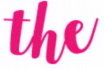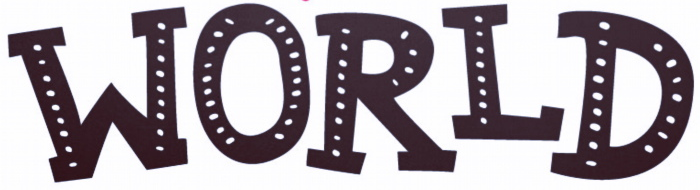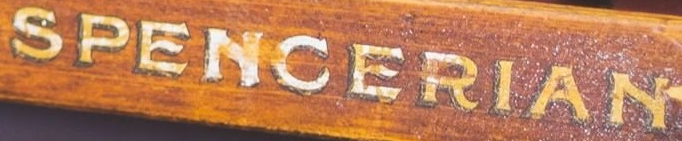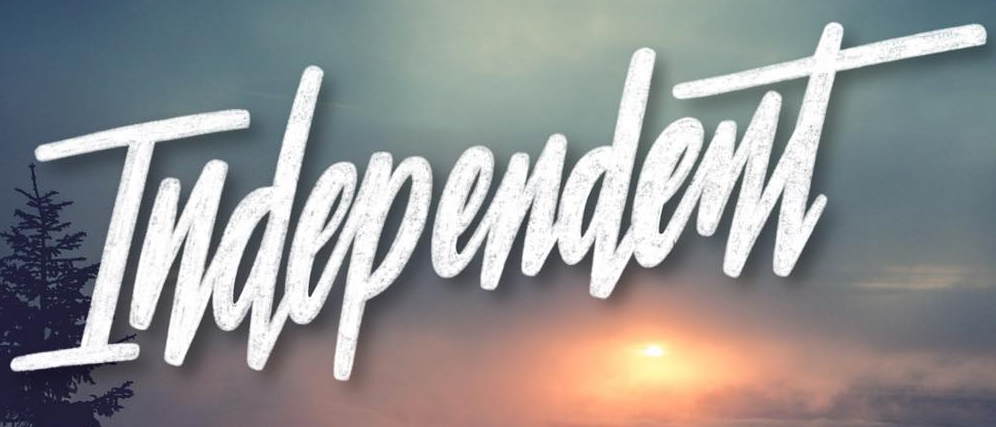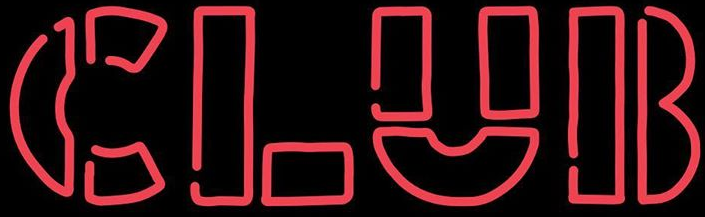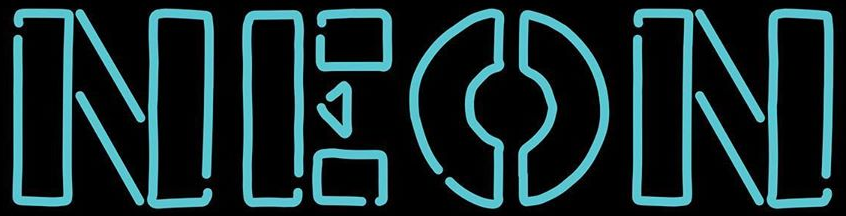What text appears in these images from left to right, separated by a semicolon? the; WORLD; SPENCERIAN; Independent; CLUB; NEON 